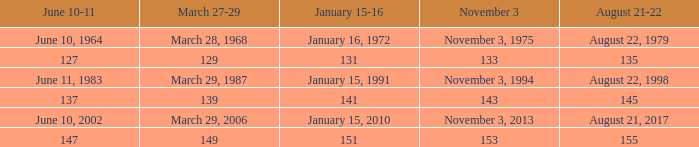What is the digit for march 27-29 when november 3 equals 153? 149.0. 